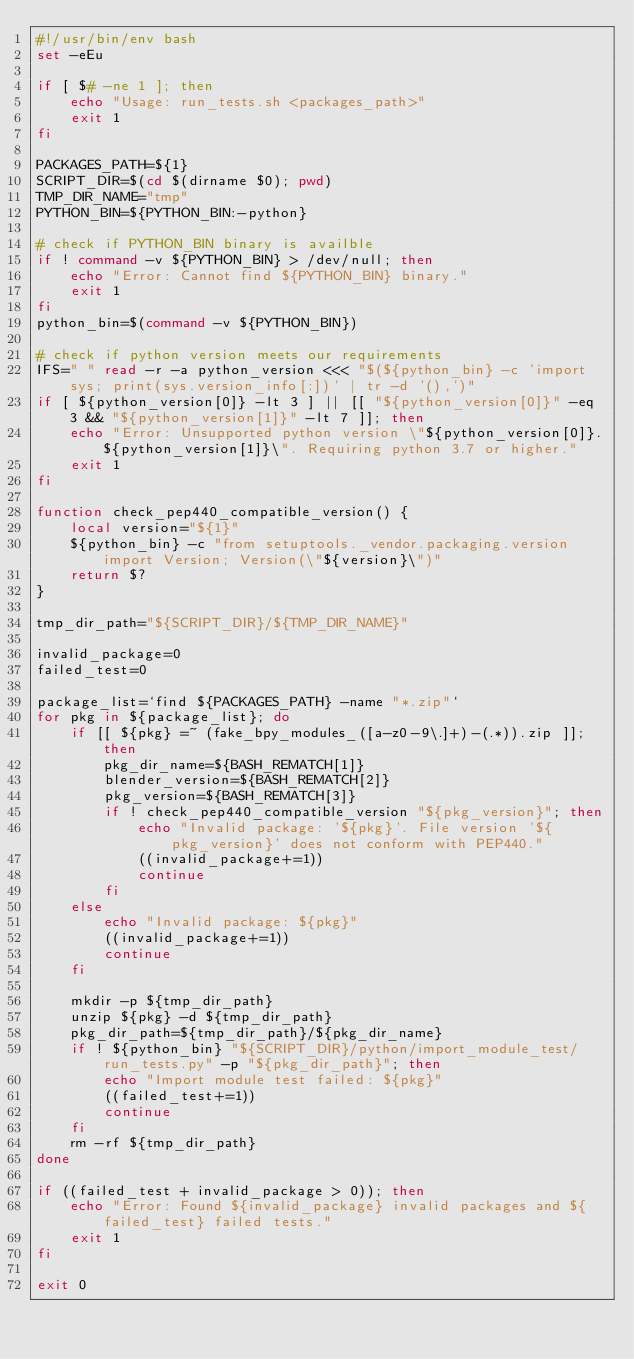Convert code to text. <code><loc_0><loc_0><loc_500><loc_500><_Bash_>#!/usr/bin/env bash
set -eEu

if [ $# -ne 1 ]; then
    echo "Usage: run_tests.sh <packages_path>"
    exit 1
fi

PACKAGES_PATH=${1}
SCRIPT_DIR=$(cd $(dirname $0); pwd)
TMP_DIR_NAME="tmp"
PYTHON_BIN=${PYTHON_BIN:-python}

# check if PYTHON_BIN binary is availble
if ! command -v ${PYTHON_BIN} > /dev/null; then
    echo "Error: Cannot find ${PYTHON_BIN} binary."
    exit 1
fi
python_bin=$(command -v ${PYTHON_BIN})

# check if python version meets our requirements
IFS=" " read -r -a python_version <<< "$(${python_bin} -c 'import sys; print(sys.version_info[:])' | tr -d '(),')"
if [ ${python_version[0]} -lt 3 ] || [[ "${python_version[0]}" -eq 3 && "${python_version[1]}" -lt 7 ]]; then
    echo "Error: Unsupported python version \"${python_version[0]}.${python_version[1]}\". Requiring python 3.7 or higher."
    exit 1
fi

function check_pep440_compatible_version() {
    local version="${1}"
    ${python_bin} -c "from setuptools._vendor.packaging.version import Version; Version(\"${version}\")"
    return $?
}

tmp_dir_path="${SCRIPT_DIR}/${TMP_DIR_NAME}"

invalid_package=0
failed_test=0

package_list=`find ${PACKAGES_PATH} -name "*.zip"`
for pkg in ${package_list}; do
    if [[ ${pkg} =~ (fake_bpy_modules_([a-z0-9\.]+)-(.*)).zip ]]; then
        pkg_dir_name=${BASH_REMATCH[1]}
        blender_version=${BASH_REMATCH[2]}
        pkg_version=${BASH_REMATCH[3]}
        if ! check_pep440_compatible_version "${pkg_version}"; then
            echo "Invalid package: '${pkg}'. File version '${pkg_version}' does not conform with PEP440."
            ((invalid_package+=1))
            continue
        fi
    else
        echo "Invalid package: ${pkg}"
        ((invalid_package+=1))
        continue
    fi

    mkdir -p ${tmp_dir_path}
    unzip ${pkg} -d ${tmp_dir_path}
    pkg_dir_path=${tmp_dir_path}/${pkg_dir_name}
    if ! ${python_bin} "${SCRIPT_DIR}/python/import_module_test/run_tests.py" -p "${pkg_dir_path}"; then
        echo "Import module test failed: ${pkg}"
        ((failed_test+=1))
        continue
    fi
    rm -rf ${tmp_dir_path}
done

if ((failed_test + invalid_package > 0)); then
    echo "Error: Found ${invalid_package} invalid packages and ${failed_test} failed tests."
    exit 1
fi

exit 0
</code> 